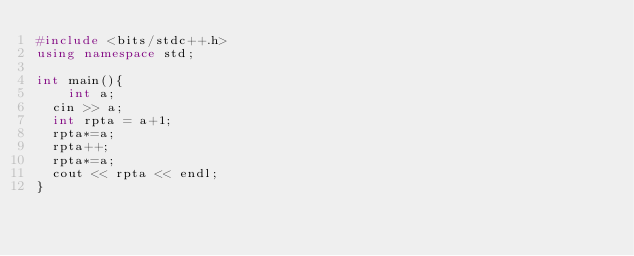<code> <loc_0><loc_0><loc_500><loc_500><_C++_>#include <bits/stdc++.h>
using namespace std;

int main(){
	int a;
  cin >> a;
  int rpta = a+1;
  rpta*=a;
  rpta++;
  rpta*=a;
  cout << rpta << endl;
}
</code> 